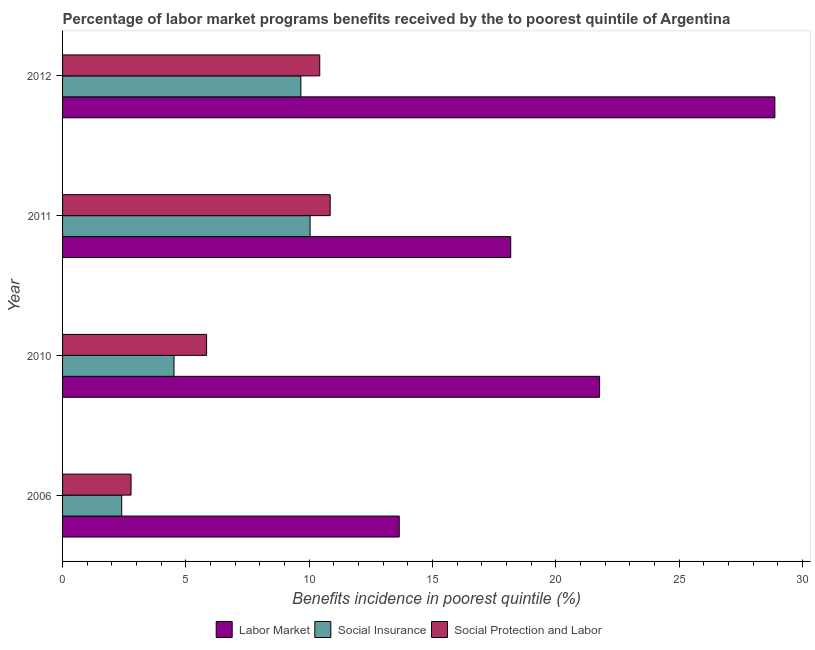Are the number of bars on each tick of the Y-axis equal?
Give a very brief answer. Yes. How many bars are there on the 4th tick from the top?
Keep it short and to the point. 3. What is the label of the 2nd group of bars from the top?
Your answer should be compact. 2011. What is the percentage of benefits received due to labor market programs in 2010?
Provide a short and direct response. 21.78. Across all years, what is the maximum percentage of benefits received due to social insurance programs?
Provide a short and direct response. 10.04. Across all years, what is the minimum percentage of benefits received due to social protection programs?
Keep it short and to the point. 2.78. What is the total percentage of benefits received due to social protection programs in the graph?
Offer a very short reply. 29.9. What is the difference between the percentage of benefits received due to social protection programs in 2011 and that in 2012?
Give a very brief answer. 0.42. What is the difference between the percentage of benefits received due to social insurance programs in 2010 and the percentage of benefits received due to labor market programs in 2011?
Your response must be concise. -13.65. What is the average percentage of benefits received due to social protection programs per year?
Give a very brief answer. 7.47. In the year 2010, what is the difference between the percentage of benefits received due to labor market programs and percentage of benefits received due to social protection programs?
Your answer should be very brief. 15.94. What is the ratio of the percentage of benefits received due to labor market programs in 2006 to that in 2011?
Provide a short and direct response. 0.75. Is the difference between the percentage of benefits received due to social protection programs in 2006 and 2010 greater than the difference between the percentage of benefits received due to social insurance programs in 2006 and 2010?
Offer a very short reply. No. What is the difference between the highest and the second highest percentage of benefits received due to social protection programs?
Provide a succinct answer. 0.42. What is the difference between the highest and the lowest percentage of benefits received due to social protection programs?
Ensure brevity in your answer.  8.07. In how many years, is the percentage of benefits received due to social insurance programs greater than the average percentage of benefits received due to social insurance programs taken over all years?
Provide a short and direct response. 2. What does the 1st bar from the top in 2010 represents?
Offer a terse response. Social Protection and Labor. What does the 1st bar from the bottom in 2011 represents?
Your response must be concise. Labor Market. Is it the case that in every year, the sum of the percentage of benefits received due to labor market programs and percentage of benefits received due to social insurance programs is greater than the percentage of benefits received due to social protection programs?
Your response must be concise. Yes. Are all the bars in the graph horizontal?
Offer a terse response. Yes. Does the graph contain any zero values?
Provide a short and direct response. No. Does the graph contain grids?
Keep it short and to the point. No. How many legend labels are there?
Your answer should be very brief. 3. What is the title of the graph?
Make the answer very short. Percentage of labor market programs benefits received by the to poorest quintile of Argentina. Does "Negligence towards kids" appear as one of the legend labels in the graph?
Provide a succinct answer. No. What is the label or title of the X-axis?
Your answer should be very brief. Benefits incidence in poorest quintile (%). What is the label or title of the Y-axis?
Provide a short and direct response. Year. What is the Benefits incidence in poorest quintile (%) of Labor Market in 2006?
Your response must be concise. 13.65. What is the Benefits incidence in poorest quintile (%) of Social Insurance in 2006?
Your answer should be very brief. 2.4. What is the Benefits incidence in poorest quintile (%) of Social Protection and Labor in 2006?
Give a very brief answer. 2.78. What is the Benefits incidence in poorest quintile (%) of Labor Market in 2010?
Offer a very short reply. 21.78. What is the Benefits incidence in poorest quintile (%) in Social Insurance in 2010?
Keep it short and to the point. 4.52. What is the Benefits incidence in poorest quintile (%) in Social Protection and Labor in 2010?
Keep it short and to the point. 5.84. What is the Benefits incidence in poorest quintile (%) of Labor Market in 2011?
Your response must be concise. 18.17. What is the Benefits incidence in poorest quintile (%) of Social Insurance in 2011?
Offer a terse response. 10.04. What is the Benefits incidence in poorest quintile (%) of Social Protection and Labor in 2011?
Offer a very short reply. 10.85. What is the Benefits incidence in poorest quintile (%) of Labor Market in 2012?
Keep it short and to the point. 28.88. What is the Benefits incidence in poorest quintile (%) of Social Insurance in 2012?
Offer a very short reply. 9.66. What is the Benefits incidence in poorest quintile (%) of Social Protection and Labor in 2012?
Ensure brevity in your answer.  10.43. Across all years, what is the maximum Benefits incidence in poorest quintile (%) in Labor Market?
Ensure brevity in your answer.  28.88. Across all years, what is the maximum Benefits incidence in poorest quintile (%) of Social Insurance?
Offer a terse response. 10.04. Across all years, what is the maximum Benefits incidence in poorest quintile (%) of Social Protection and Labor?
Make the answer very short. 10.85. Across all years, what is the minimum Benefits incidence in poorest quintile (%) of Labor Market?
Your answer should be very brief. 13.65. Across all years, what is the minimum Benefits incidence in poorest quintile (%) in Social Insurance?
Your answer should be very brief. 2.4. Across all years, what is the minimum Benefits incidence in poorest quintile (%) in Social Protection and Labor?
Ensure brevity in your answer.  2.78. What is the total Benefits incidence in poorest quintile (%) of Labor Market in the graph?
Provide a succinct answer. 82.48. What is the total Benefits incidence in poorest quintile (%) in Social Insurance in the graph?
Your answer should be compact. 26.62. What is the total Benefits incidence in poorest quintile (%) in Social Protection and Labor in the graph?
Your answer should be compact. 29.9. What is the difference between the Benefits incidence in poorest quintile (%) in Labor Market in 2006 and that in 2010?
Give a very brief answer. -8.12. What is the difference between the Benefits incidence in poorest quintile (%) in Social Insurance in 2006 and that in 2010?
Your answer should be very brief. -2.12. What is the difference between the Benefits incidence in poorest quintile (%) of Social Protection and Labor in 2006 and that in 2010?
Offer a terse response. -3.06. What is the difference between the Benefits incidence in poorest quintile (%) of Labor Market in 2006 and that in 2011?
Make the answer very short. -4.52. What is the difference between the Benefits incidence in poorest quintile (%) of Social Insurance in 2006 and that in 2011?
Ensure brevity in your answer.  -7.64. What is the difference between the Benefits incidence in poorest quintile (%) of Social Protection and Labor in 2006 and that in 2011?
Your answer should be compact. -8.07. What is the difference between the Benefits incidence in poorest quintile (%) of Labor Market in 2006 and that in 2012?
Ensure brevity in your answer.  -15.23. What is the difference between the Benefits incidence in poorest quintile (%) in Social Insurance in 2006 and that in 2012?
Your answer should be compact. -7.26. What is the difference between the Benefits incidence in poorest quintile (%) of Social Protection and Labor in 2006 and that in 2012?
Provide a short and direct response. -7.65. What is the difference between the Benefits incidence in poorest quintile (%) in Labor Market in 2010 and that in 2011?
Ensure brevity in your answer.  3.6. What is the difference between the Benefits incidence in poorest quintile (%) in Social Insurance in 2010 and that in 2011?
Your answer should be compact. -5.52. What is the difference between the Benefits incidence in poorest quintile (%) in Social Protection and Labor in 2010 and that in 2011?
Your answer should be compact. -5.01. What is the difference between the Benefits incidence in poorest quintile (%) in Labor Market in 2010 and that in 2012?
Provide a short and direct response. -7.11. What is the difference between the Benefits incidence in poorest quintile (%) of Social Insurance in 2010 and that in 2012?
Offer a terse response. -5.14. What is the difference between the Benefits incidence in poorest quintile (%) of Social Protection and Labor in 2010 and that in 2012?
Your response must be concise. -4.59. What is the difference between the Benefits incidence in poorest quintile (%) of Labor Market in 2011 and that in 2012?
Provide a short and direct response. -10.71. What is the difference between the Benefits incidence in poorest quintile (%) of Social Insurance in 2011 and that in 2012?
Provide a short and direct response. 0.37. What is the difference between the Benefits incidence in poorest quintile (%) of Social Protection and Labor in 2011 and that in 2012?
Your answer should be compact. 0.42. What is the difference between the Benefits incidence in poorest quintile (%) of Labor Market in 2006 and the Benefits incidence in poorest quintile (%) of Social Insurance in 2010?
Keep it short and to the point. 9.13. What is the difference between the Benefits incidence in poorest quintile (%) in Labor Market in 2006 and the Benefits incidence in poorest quintile (%) in Social Protection and Labor in 2010?
Ensure brevity in your answer.  7.81. What is the difference between the Benefits incidence in poorest quintile (%) in Social Insurance in 2006 and the Benefits incidence in poorest quintile (%) in Social Protection and Labor in 2010?
Keep it short and to the point. -3.44. What is the difference between the Benefits incidence in poorest quintile (%) in Labor Market in 2006 and the Benefits incidence in poorest quintile (%) in Social Insurance in 2011?
Make the answer very short. 3.62. What is the difference between the Benefits incidence in poorest quintile (%) of Labor Market in 2006 and the Benefits incidence in poorest quintile (%) of Social Protection and Labor in 2011?
Your response must be concise. 2.8. What is the difference between the Benefits incidence in poorest quintile (%) in Social Insurance in 2006 and the Benefits incidence in poorest quintile (%) in Social Protection and Labor in 2011?
Ensure brevity in your answer.  -8.45. What is the difference between the Benefits incidence in poorest quintile (%) of Labor Market in 2006 and the Benefits incidence in poorest quintile (%) of Social Insurance in 2012?
Offer a terse response. 3.99. What is the difference between the Benefits incidence in poorest quintile (%) in Labor Market in 2006 and the Benefits incidence in poorest quintile (%) in Social Protection and Labor in 2012?
Your answer should be compact. 3.22. What is the difference between the Benefits incidence in poorest quintile (%) of Social Insurance in 2006 and the Benefits incidence in poorest quintile (%) of Social Protection and Labor in 2012?
Your response must be concise. -8.03. What is the difference between the Benefits incidence in poorest quintile (%) of Labor Market in 2010 and the Benefits incidence in poorest quintile (%) of Social Insurance in 2011?
Offer a terse response. 11.74. What is the difference between the Benefits incidence in poorest quintile (%) of Labor Market in 2010 and the Benefits incidence in poorest quintile (%) of Social Protection and Labor in 2011?
Give a very brief answer. 10.93. What is the difference between the Benefits incidence in poorest quintile (%) in Social Insurance in 2010 and the Benefits incidence in poorest quintile (%) in Social Protection and Labor in 2011?
Your answer should be very brief. -6.33. What is the difference between the Benefits incidence in poorest quintile (%) of Labor Market in 2010 and the Benefits incidence in poorest quintile (%) of Social Insurance in 2012?
Your answer should be compact. 12.11. What is the difference between the Benefits incidence in poorest quintile (%) in Labor Market in 2010 and the Benefits incidence in poorest quintile (%) in Social Protection and Labor in 2012?
Offer a very short reply. 11.35. What is the difference between the Benefits incidence in poorest quintile (%) of Social Insurance in 2010 and the Benefits incidence in poorest quintile (%) of Social Protection and Labor in 2012?
Your response must be concise. -5.91. What is the difference between the Benefits incidence in poorest quintile (%) of Labor Market in 2011 and the Benefits incidence in poorest quintile (%) of Social Insurance in 2012?
Your answer should be compact. 8.51. What is the difference between the Benefits incidence in poorest quintile (%) of Labor Market in 2011 and the Benefits incidence in poorest quintile (%) of Social Protection and Labor in 2012?
Give a very brief answer. 7.74. What is the difference between the Benefits incidence in poorest quintile (%) of Social Insurance in 2011 and the Benefits incidence in poorest quintile (%) of Social Protection and Labor in 2012?
Your answer should be compact. -0.39. What is the average Benefits incidence in poorest quintile (%) in Labor Market per year?
Make the answer very short. 20.62. What is the average Benefits incidence in poorest quintile (%) in Social Insurance per year?
Your response must be concise. 6.65. What is the average Benefits incidence in poorest quintile (%) in Social Protection and Labor per year?
Your answer should be very brief. 7.47. In the year 2006, what is the difference between the Benefits incidence in poorest quintile (%) in Labor Market and Benefits incidence in poorest quintile (%) in Social Insurance?
Your answer should be very brief. 11.25. In the year 2006, what is the difference between the Benefits incidence in poorest quintile (%) of Labor Market and Benefits incidence in poorest quintile (%) of Social Protection and Labor?
Your answer should be very brief. 10.88. In the year 2006, what is the difference between the Benefits incidence in poorest quintile (%) of Social Insurance and Benefits incidence in poorest quintile (%) of Social Protection and Labor?
Offer a very short reply. -0.38. In the year 2010, what is the difference between the Benefits incidence in poorest quintile (%) of Labor Market and Benefits incidence in poorest quintile (%) of Social Insurance?
Your answer should be compact. 17.26. In the year 2010, what is the difference between the Benefits incidence in poorest quintile (%) in Labor Market and Benefits incidence in poorest quintile (%) in Social Protection and Labor?
Make the answer very short. 15.94. In the year 2010, what is the difference between the Benefits incidence in poorest quintile (%) of Social Insurance and Benefits incidence in poorest quintile (%) of Social Protection and Labor?
Keep it short and to the point. -1.32. In the year 2011, what is the difference between the Benefits incidence in poorest quintile (%) of Labor Market and Benefits incidence in poorest quintile (%) of Social Insurance?
Offer a terse response. 8.14. In the year 2011, what is the difference between the Benefits incidence in poorest quintile (%) in Labor Market and Benefits incidence in poorest quintile (%) in Social Protection and Labor?
Provide a short and direct response. 7.32. In the year 2011, what is the difference between the Benefits incidence in poorest quintile (%) of Social Insurance and Benefits incidence in poorest quintile (%) of Social Protection and Labor?
Offer a terse response. -0.81. In the year 2012, what is the difference between the Benefits incidence in poorest quintile (%) in Labor Market and Benefits incidence in poorest quintile (%) in Social Insurance?
Ensure brevity in your answer.  19.22. In the year 2012, what is the difference between the Benefits incidence in poorest quintile (%) in Labor Market and Benefits incidence in poorest quintile (%) in Social Protection and Labor?
Give a very brief answer. 18.45. In the year 2012, what is the difference between the Benefits incidence in poorest quintile (%) of Social Insurance and Benefits incidence in poorest quintile (%) of Social Protection and Labor?
Your response must be concise. -0.77. What is the ratio of the Benefits incidence in poorest quintile (%) of Labor Market in 2006 to that in 2010?
Your answer should be very brief. 0.63. What is the ratio of the Benefits incidence in poorest quintile (%) in Social Insurance in 2006 to that in 2010?
Provide a short and direct response. 0.53. What is the ratio of the Benefits incidence in poorest quintile (%) in Social Protection and Labor in 2006 to that in 2010?
Your answer should be compact. 0.48. What is the ratio of the Benefits incidence in poorest quintile (%) in Labor Market in 2006 to that in 2011?
Offer a very short reply. 0.75. What is the ratio of the Benefits incidence in poorest quintile (%) of Social Insurance in 2006 to that in 2011?
Make the answer very short. 0.24. What is the ratio of the Benefits incidence in poorest quintile (%) of Social Protection and Labor in 2006 to that in 2011?
Keep it short and to the point. 0.26. What is the ratio of the Benefits incidence in poorest quintile (%) of Labor Market in 2006 to that in 2012?
Keep it short and to the point. 0.47. What is the ratio of the Benefits incidence in poorest quintile (%) in Social Insurance in 2006 to that in 2012?
Give a very brief answer. 0.25. What is the ratio of the Benefits incidence in poorest quintile (%) in Social Protection and Labor in 2006 to that in 2012?
Provide a short and direct response. 0.27. What is the ratio of the Benefits incidence in poorest quintile (%) of Labor Market in 2010 to that in 2011?
Your response must be concise. 1.2. What is the ratio of the Benefits incidence in poorest quintile (%) of Social Insurance in 2010 to that in 2011?
Give a very brief answer. 0.45. What is the ratio of the Benefits incidence in poorest quintile (%) in Social Protection and Labor in 2010 to that in 2011?
Give a very brief answer. 0.54. What is the ratio of the Benefits incidence in poorest quintile (%) of Labor Market in 2010 to that in 2012?
Your answer should be very brief. 0.75. What is the ratio of the Benefits incidence in poorest quintile (%) of Social Insurance in 2010 to that in 2012?
Provide a succinct answer. 0.47. What is the ratio of the Benefits incidence in poorest quintile (%) in Social Protection and Labor in 2010 to that in 2012?
Make the answer very short. 0.56. What is the ratio of the Benefits incidence in poorest quintile (%) in Labor Market in 2011 to that in 2012?
Your answer should be very brief. 0.63. What is the ratio of the Benefits incidence in poorest quintile (%) of Social Insurance in 2011 to that in 2012?
Your answer should be compact. 1.04. What is the ratio of the Benefits incidence in poorest quintile (%) of Social Protection and Labor in 2011 to that in 2012?
Offer a terse response. 1.04. What is the difference between the highest and the second highest Benefits incidence in poorest quintile (%) in Labor Market?
Keep it short and to the point. 7.11. What is the difference between the highest and the second highest Benefits incidence in poorest quintile (%) in Social Insurance?
Provide a short and direct response. 0.37. What is the difference between the highest and the second highest Benefits incidence in poorest quintile (%) in Social Protection and Labor?
Keep it short and to the point. 0.42. What is the difference between the highest and the lowest Benefits incidence in poorest quintile (%) in Labor Market?
Your answer should be very brief. 15.23. What is the difference between the highest and the lowest Benefits incidence in poorest quintile (%) of Social Insurance?
Offer a terse response. 7.64. What is the difference between the highest and the lowest Benefits incidence in poorest quintile (%) in Social Protection and Labor?
Keep it short and to the point. 8.07. 